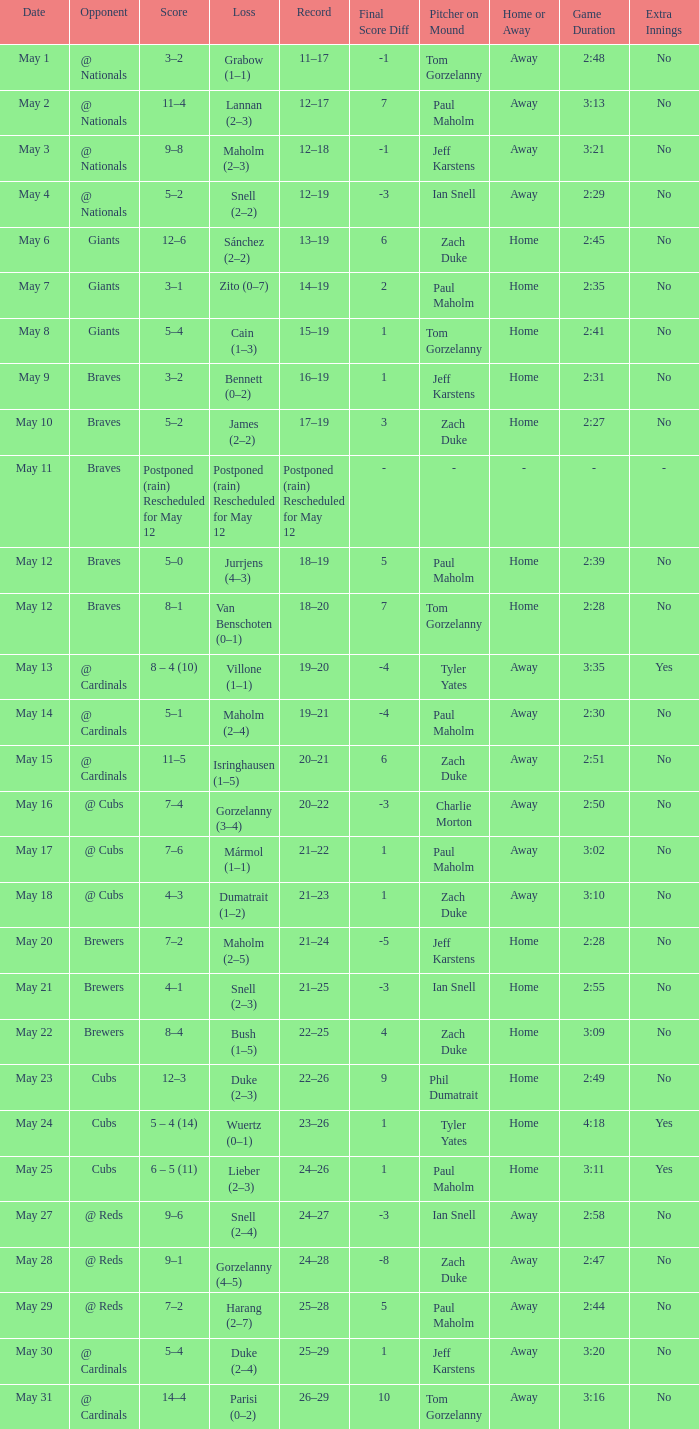Who was the opponent at the game with a score of 7–6? @ Cubs. 